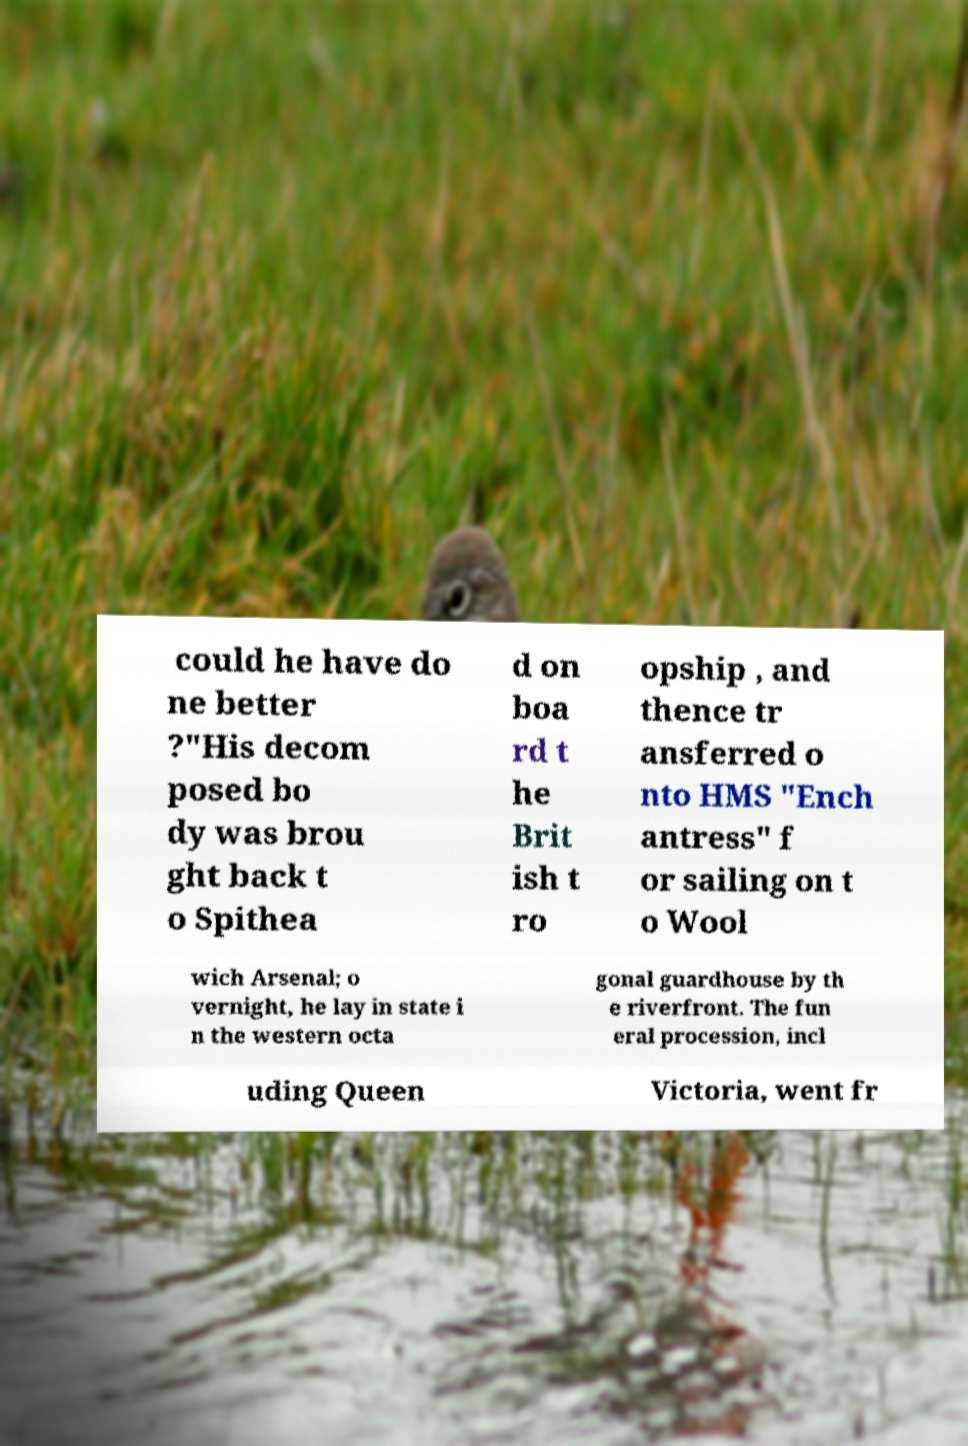Can you read and provide the text displayed in the image?This photo seems to have some interesting text. Can you extract and type it out for me? could he have do ne better ?"His decom posed bo dy was brou ght back t o Spithea d on boa rd t he Brit ish t ro opship , and thence tr ansferred o nto HMS "Ench antress" f or sailing on t o Wool wich Arsenal; o vernight, he lay in state i n the western octa gonal guardhouse by th e riverfront. The fun eral procession, incl uding Queen Victoria, went fr 